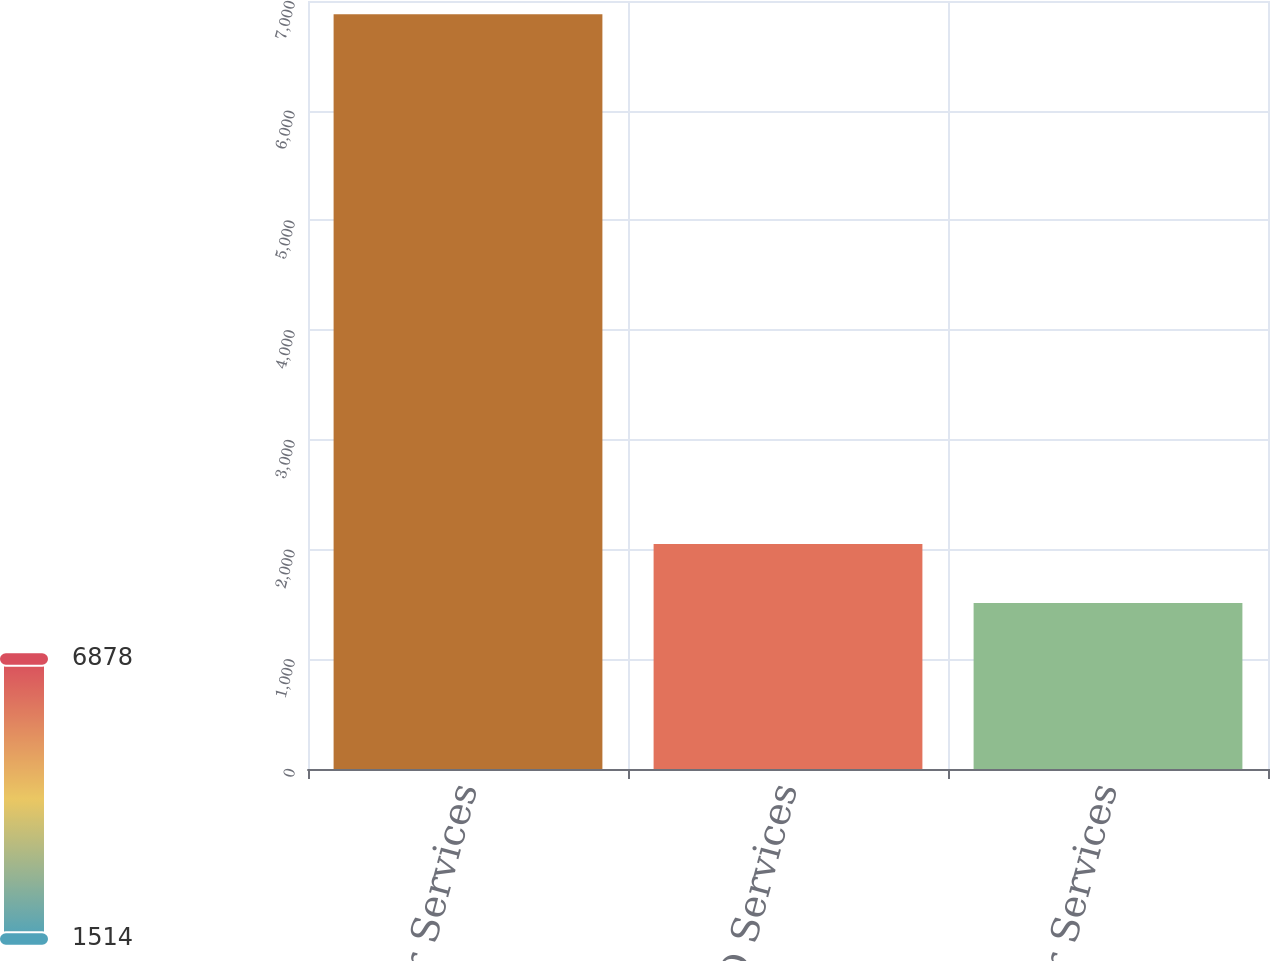Convert chart to OTSL. <chart><loc_0><loc_0><loc_500><loc_500><bar_chart><fcel>Employer Services<fcel>PEO Services<fcel>Dealer Services<nl><fcel>6878.3<fcel>2049.98<fcel>1513.5<nl></chart> 